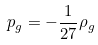<formula> <loc_0><loc_0><loc_500><loc_500>p _ { g } = - \frac { 1 } { 2 7 } \rho _ { g }</formula> 